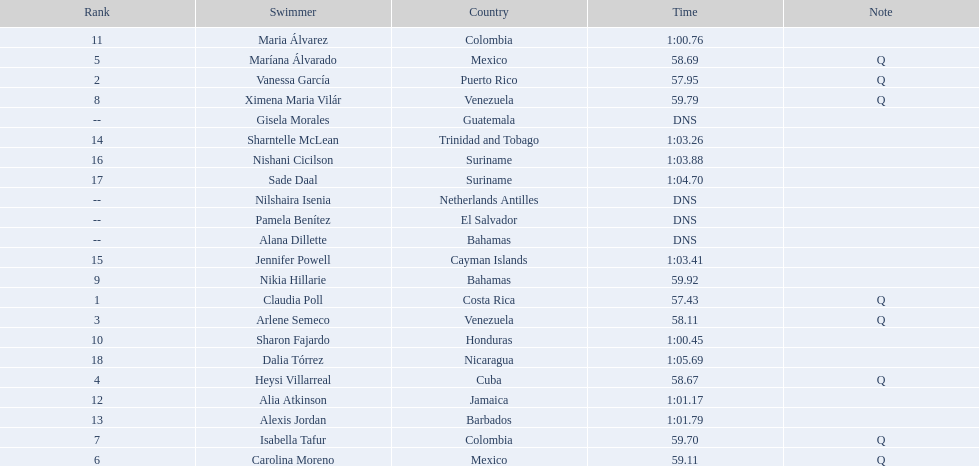Who were the swimmers at the 2006 central american and caribbean games - women's 100 metre freestyle? Claudia Poll, Vanessa García, Arlene Semeco, Heysi Villarreal, Maríana Álvarado, Carolina Moreno, Isabella Tafur, Ximena Maria Vilár, Nikia Hillarie, Sharon Fajardo, Maria Álvarez, Alia Atkinson, Alexis Jordan, Sharntelle McLean, Jennifer Powell, Nishani Cicilson, Sade Daal, Dalia Tórrez, Gisela Morales, Alana Dillette, Pamela Benítez, Nilshaira Isenia. Would you be able to parse every entry in this table? {'header': ['Rank', 'Swimmer', 'Country', 'Time', 'Note'], 'rows': [['11', 'Maria Álvarez', 'Colombia', '1:00.76', ''], ['5', 'Maríana Álvarado', 'Mexico', '58.69', 'Q'], ['2', 'Vanessa García', 'Puerto Rico', '57.95', 'Q'], ['8', 'Ximena Maria Vilár', 'Venezuela', '59.79', 'Q'], ['--', 'Gisela Morales', 'Guatemala', 'DNS', ''], ['14', 'Sharntelle McLean', 'Trinidad and Tobago', '1:03.26', ''], ['16', 'Nishani Cicilson', 'Suriname', '1:03.88', ''], ['17', 'Sade Daal', 'Suriname', '1:04.70', ''], ['--', 'Nilshaira Isenia', 'Netherlands Antilles', 'DNS', ''], ['--', 'Pamela Benítez', 'El Salvador', 'DNS', ''], ['--', 'Alana Dillette', 'Bahamas', 'DNS', ''], ['15', 'Jennifer Powell', 'Cayman Islands', '1:03.41', ''], ['9', 'Nikia Hillarie', 'Bahamas', '59.92', ''], ['1', 'Claudia Poll', 'Costa Rica', '57.43', 'Q'], ['3', 'Arlene Semeco', 'Venezuela', '58.11', 'Q'], ['10', 'Sharon Fajardo', 'Honduras', '1:00.45', ''], ['18', 'Dalia Tórrez', 'Nicaragua', '1:05.69', ''], ['4', 'Heysi Villarreal', 'Cuba', '58.67', 'Q'], ['12', 'Alia Atkinson', 'Jamaica', '1:01.17', ''], ['13', 'Alexis Jordan', 'Barbados', '1:01.79', ''], ['7', 'Isabella Tafur', 'Colombia', '59.70', 'Q'], ['6', 'Carolina Moreno', 'Mexico', '59.11', 'Q']]} Of these which were from cuba? Heysi Villarreal. 